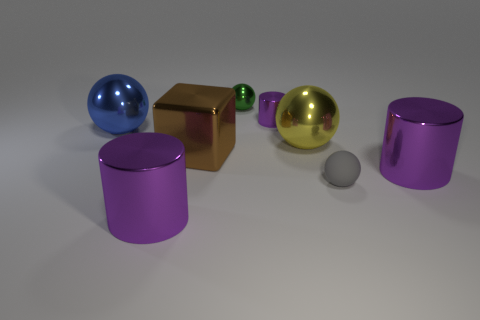How many purple cylinders must be subtracted to get 1 purple cylinders? 2 Subtract all small purple cylinders. How many cylinders are left? 2 Add 2 tiny green cubes. How many objects exist? 10 Subtract all gray balls. How many balls are left? 3 Subtract 4 spheres. How many spheres are left? 0 Add 5 purple things. How many purple things are left? 8 Add 1 blue metallic things. How many blue metallic things exist? 2 Subtract 1 green spheres. How many objects are left? 7 Subtract all blocks. How many objects are left? 7 Subtract all blue balls. Subtract all cyan blocks. How many balls are left? 3 